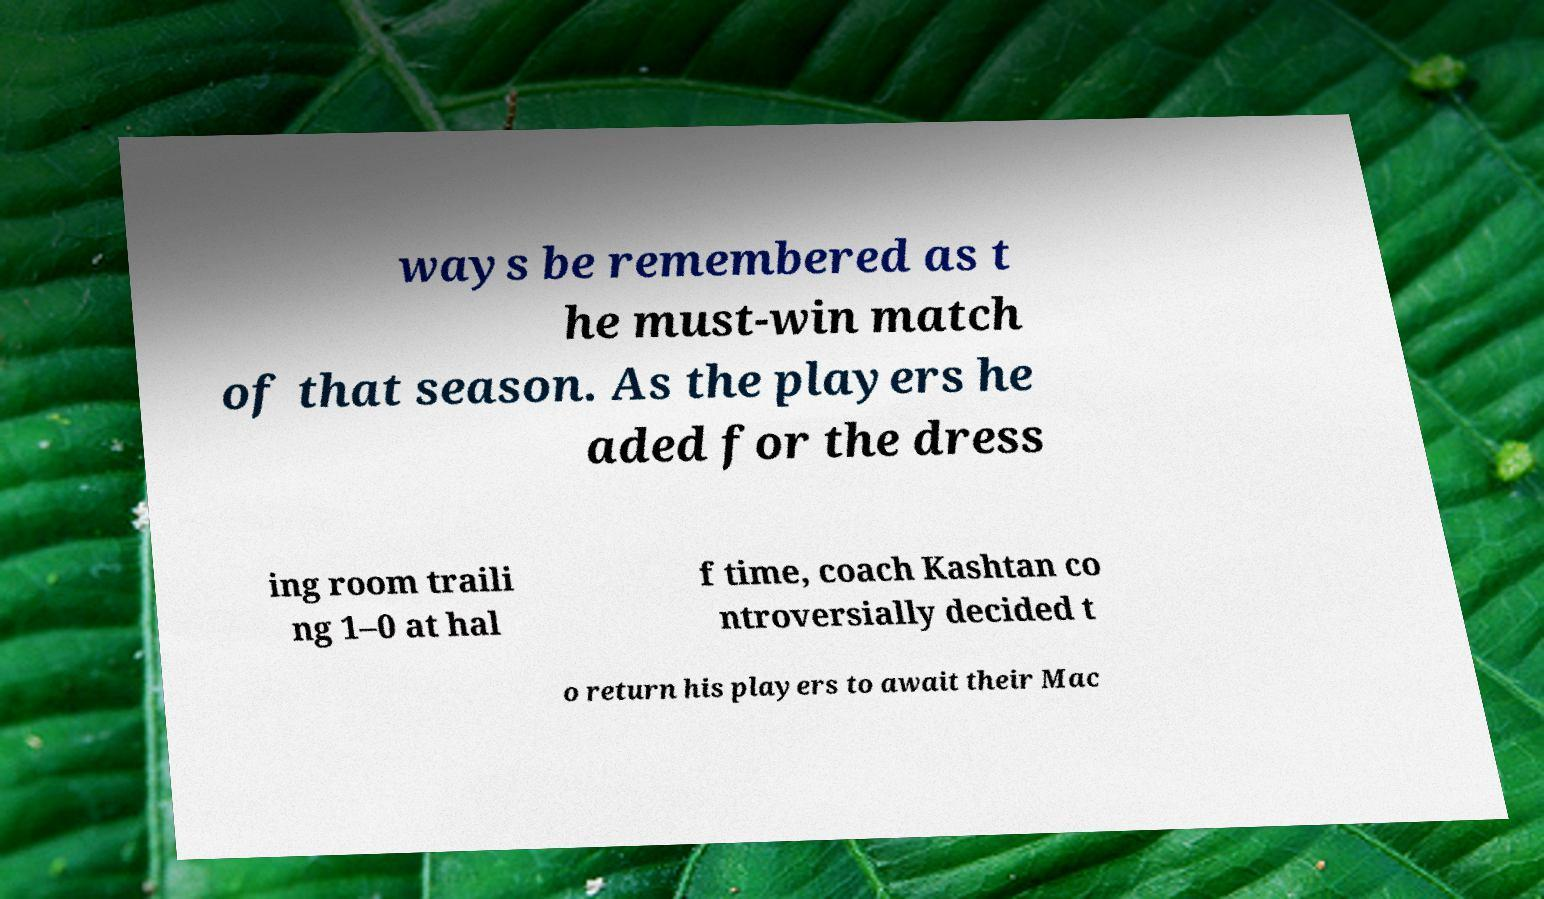Could you assist in decoding the text presented in this image and type it out clearly? ways be remembered as t he must-win match of that season. As the players he aded for the dress ing room traili ng 1–0 at hal f time, coach Kashtan co ntroversially decided t o return his players to await their Mac 